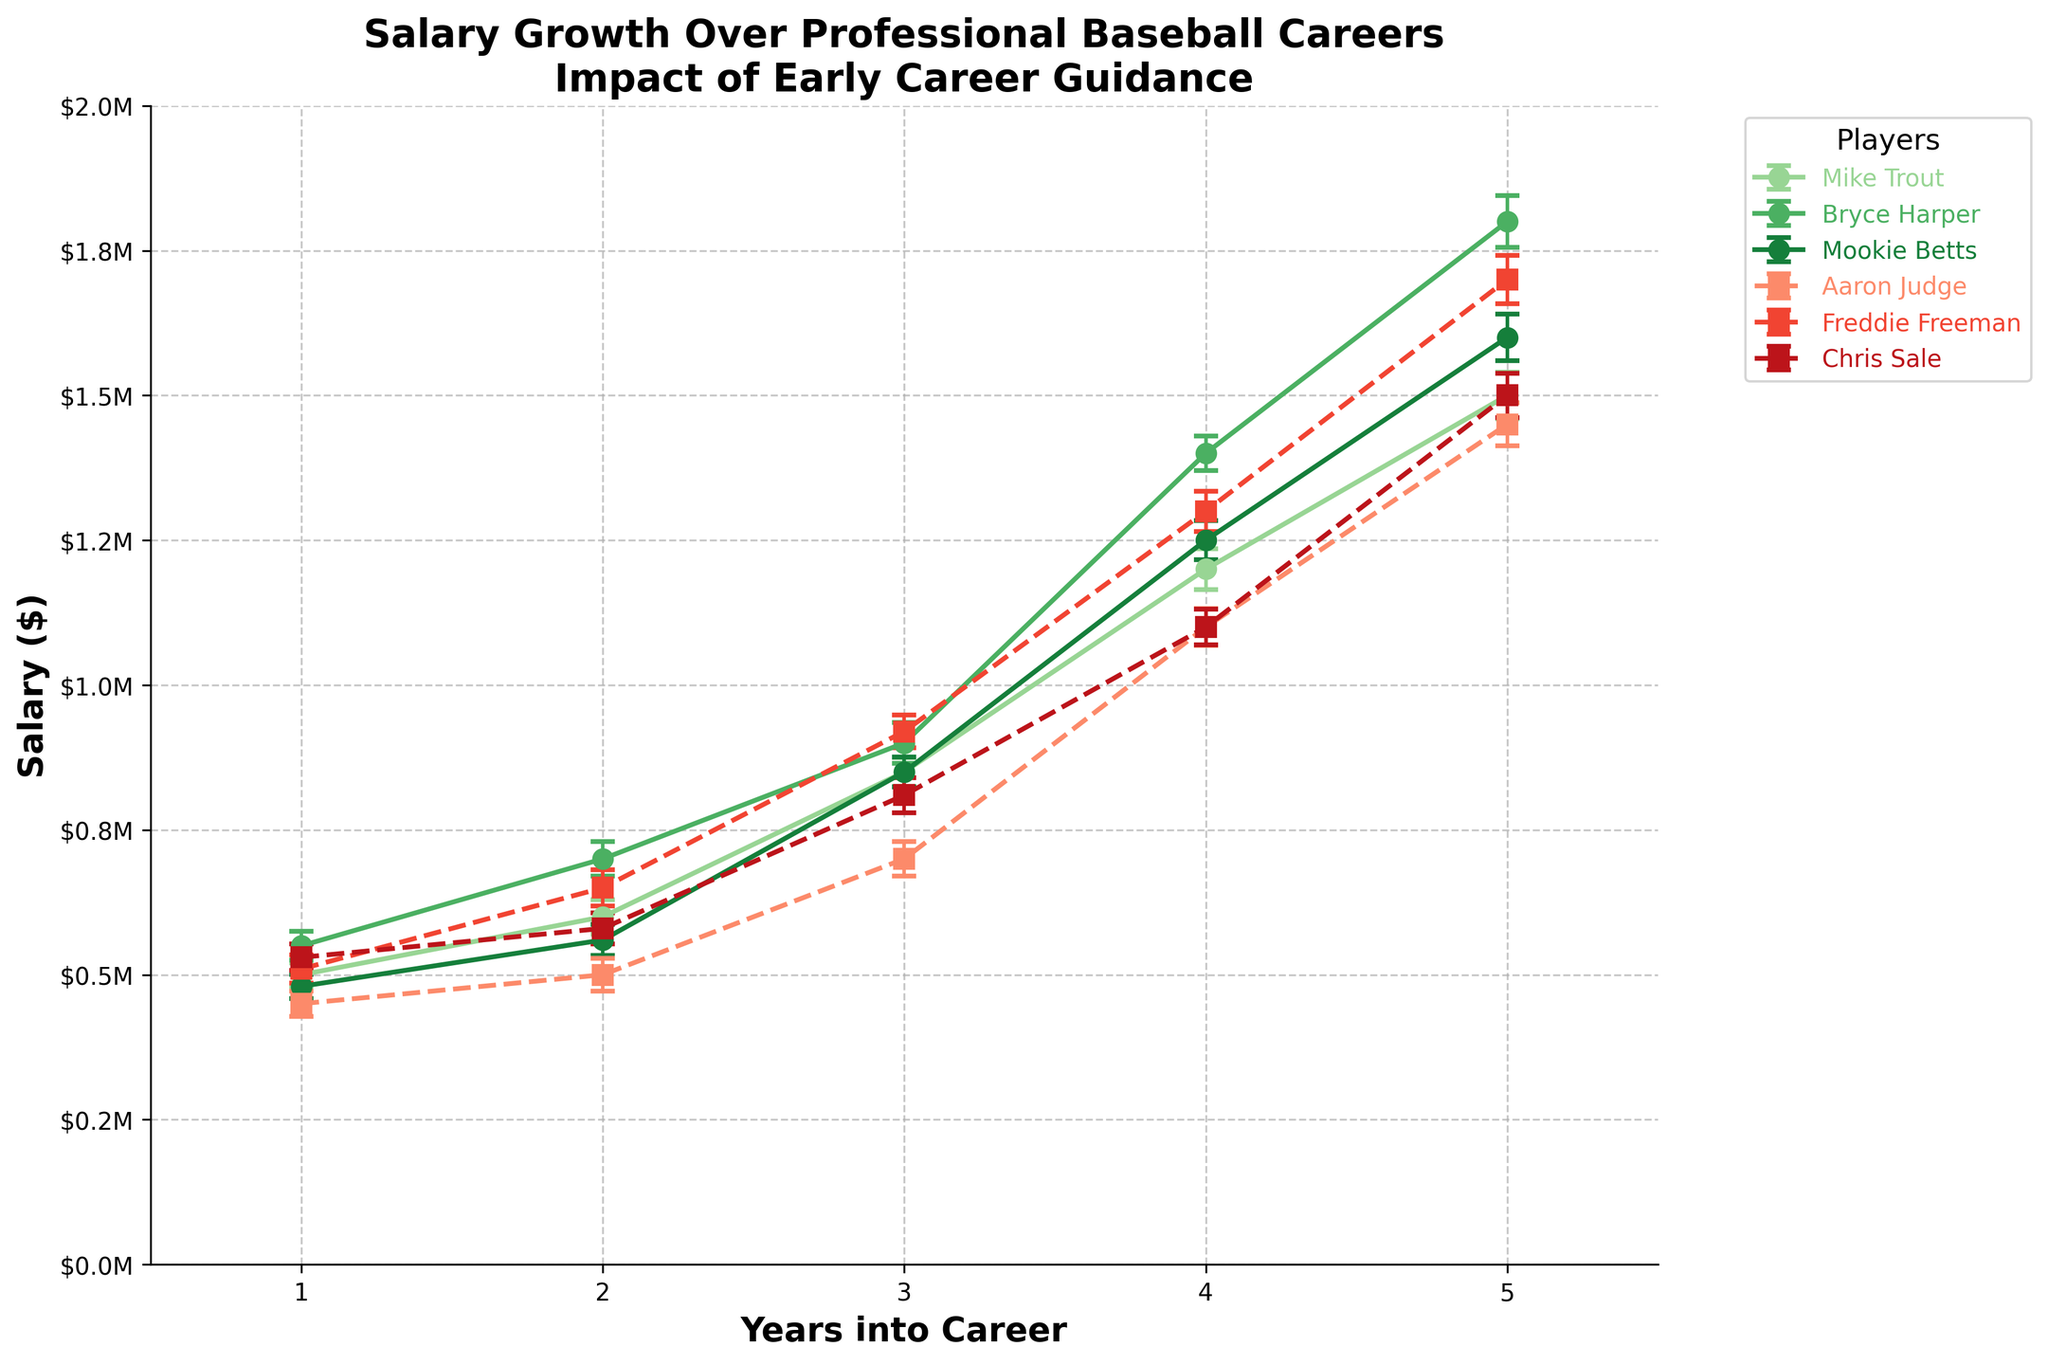What is the title of the figure? The title is located at the top of the figure and is typically formatted in bold and larger font size for emphasis.
Answer: Salary Growth Over Professional Baseball Careers Impact of Early Career Guidance What are the x-axis and y-axis labels? The x-axis and y-axis labels are typically found below and to the left of the plot, respectively. Both axes serve to describe the context of the data presented.
Answer: x-axis: Years into Career, y-axis: Salary ($) Which players received early career guidance? The legend on the right-hand side of the plot indicates which players received early career guidance by their match with the color scheme used in the plot. Players with green lines received guidance.
Answer: Mike Trout, Bryce Harper, Mookie Betts How does the salary growth of Bryce Harper compare to that of Aaron Judge over their careers? By evaluating both plots, we see that Bryce Harper's salary grows more consistently and to a higher maximum than Aaron Judge's, with the former reaching $1.8M by year 5 and the latter around $1.45M.
Answer: Bryce Harper's salary grows higher and more consistently What is the average salary for Freddie Freeman over the first three years of his career? Identifying Freddie Freeman's salary from each of the first three years ($510,000, $650,000, $920,000), add them and then divide by the number of years: (510000 + 650000 + 920000) / 3 = 693333.33.
Answer: $693,333.33 Which player has the highest salary in year 2 among those without guidance? Reviewing the data for year 2 among all players without guidance, look for the maximum salary. Freddie Freeman's salary in year 2 is $650,000, which is the highest.
Answer: Freddie Freeman What is the overall trend in salary growth for players who received early career guidance compared to those who did not? Evaluating the set of plots, the salary trends show that players with early career guidance generally experience more significant wage increases and higher overall salaries across the same timeframe than those without guidance.
Answer: More significant wage increases and higher overall salaries In terms of error margins, which player shows the largest error in year 5? Reviewing the error bars in year 5 for each player, Bryce Harper has the largest error margin, represented by the size of the ± error bar.
Answer: Bryce Harper 